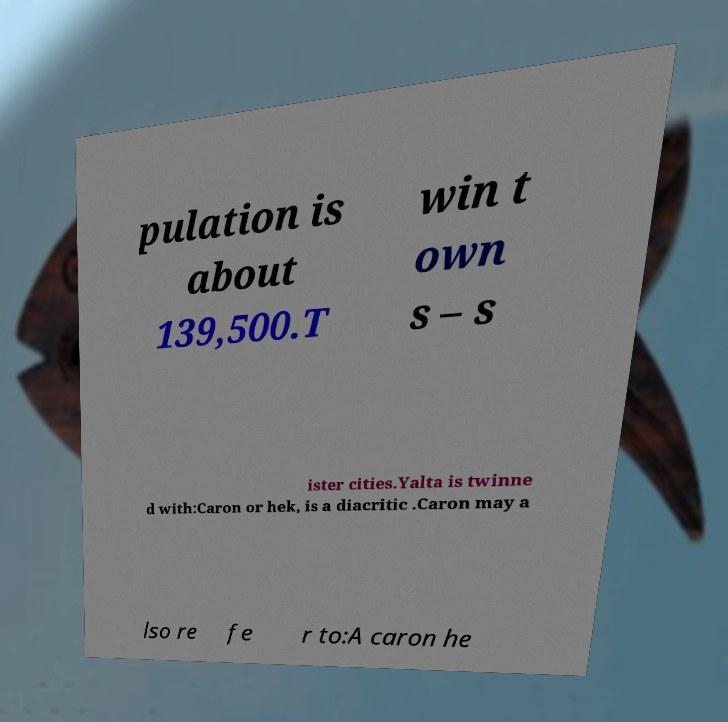Please read and relay the text visible in this image. What does it say? pulation is about 139,500.T win t own s – s ister cities.Yalta is twinne d with:Caron or hek, is a diacritic .Caron may a lso re fe r to:A caron he 